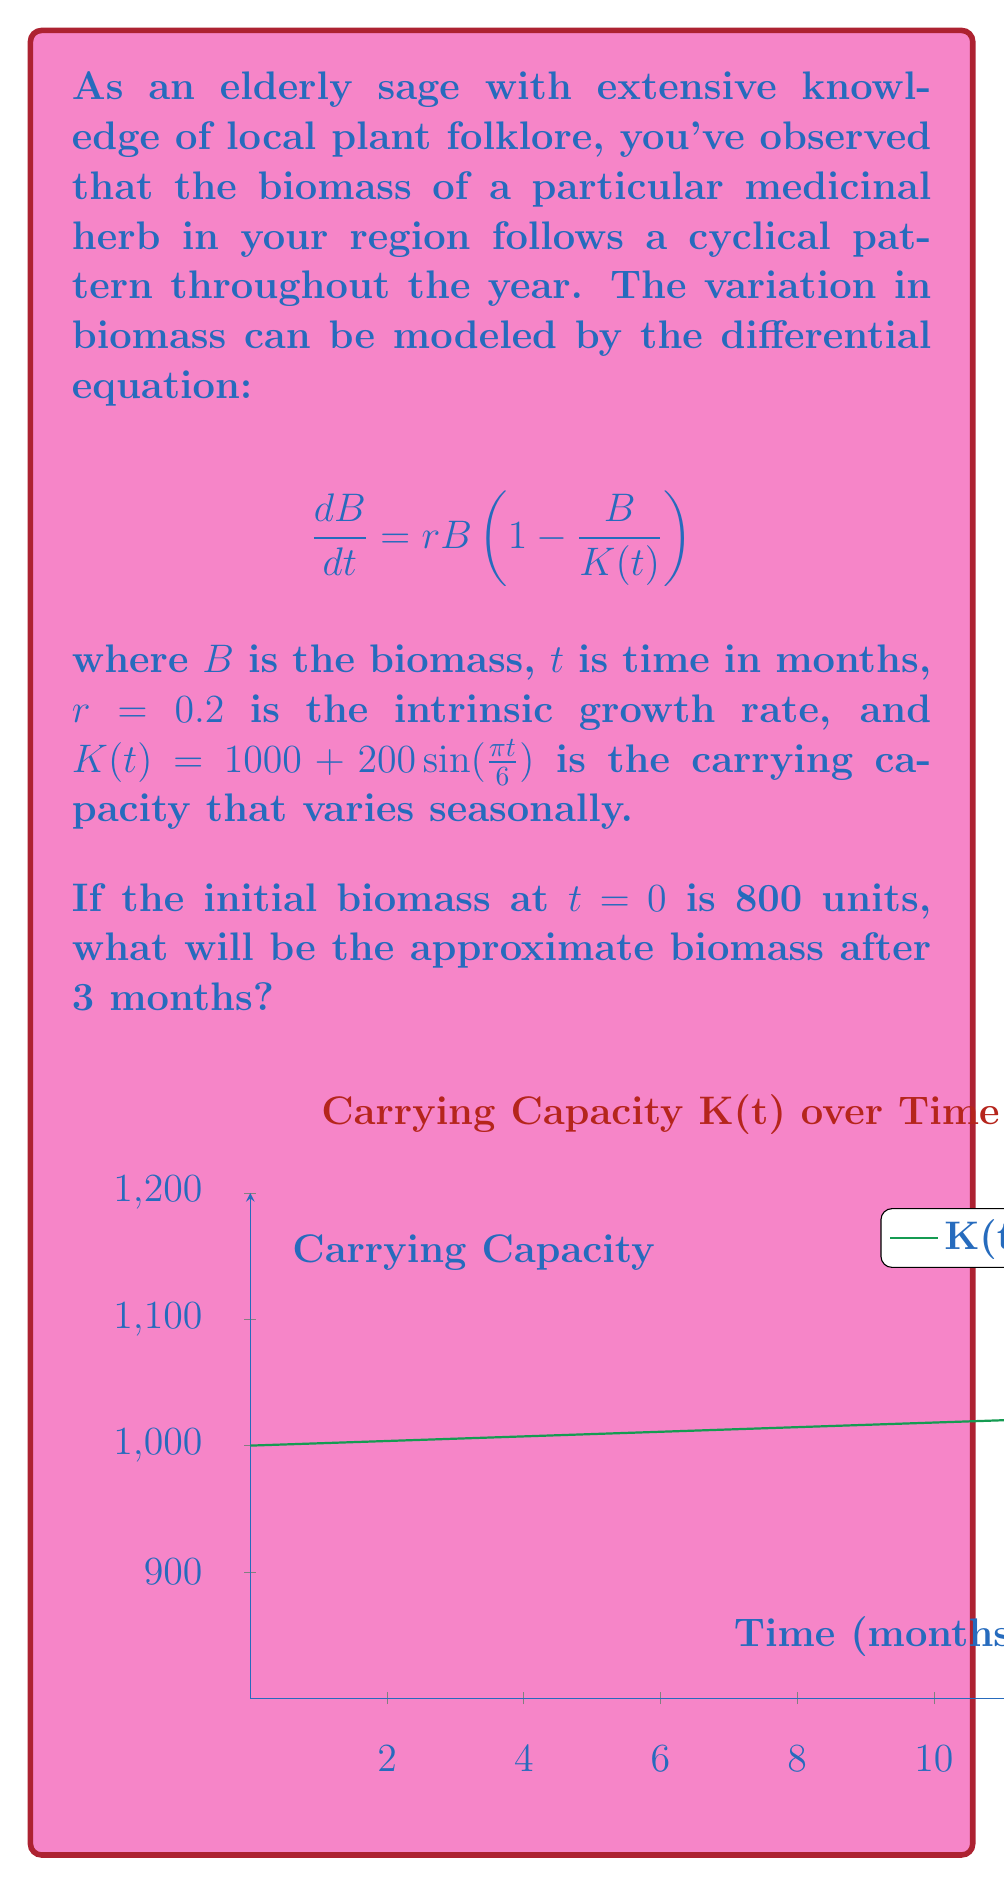Can you solve this math problem? To solve this problem, we'll follow these steps:

1) The given differential equation is a logistic growth model with a time-varying carrying capacity. It doesn't have a simple analytical solution, so we'll use numerical methods.

2) We can use Euler's method to approximate the solution. The Euler's method formula is:

   $$B_{n+1} = B_n + h \cdot f(t_n, B_n)$$

   where $h$ is the step size and $f(t, B) = rB(1 - \frac{B}{K(t)})$.

3) Let's use a step size of $h = 0.1$ months. We need to iterate 30 times to reach 3 months.

4) At each step, we calculate:

   $$B_{n+1} = B_n + 0.1 \cdot 0.2B_n\left(1 - \frac{B_n}{1000 + 200\sin(\frac{\pi t_n}{6})}\right)$$

5) Starting with $B_0 = 800$, we iterate:

   $B_1 = 800 + 0.1 \cdot 0.2 \cdot 800 \cdot (1 - \frac{800}{1000}) = 803.2$
   $B_2 = 803.2 + 0.1 \cdot 0.2 \cdot 803.2 \cdot (1 - \frac{803.2}{1000.52}) = 806.38$
   ...

6) After 30 iterations, we get $B_{30} \approx 891.5$.

Therefore, after 3 months, the biomass will be approximately 891.5 units.
Answer: 891.5 units 